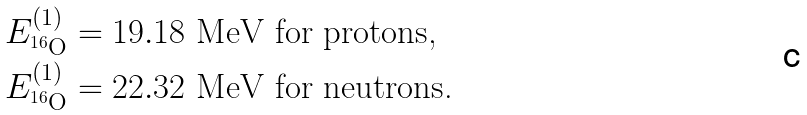<formula> <loc_0><loc_0><loc_500><loc_500>E ^ { ( 1 ) } _ { ^ { 1 6 } \text {O} } & = 1 9 . 1 8 \text { MeV for protons,} \\ E ^ { ( 1 ) } _ { ^ { 1 6 } \text {O} } & = 2 2 . 3 2 \text { MeV for neutrons.}</formula> 